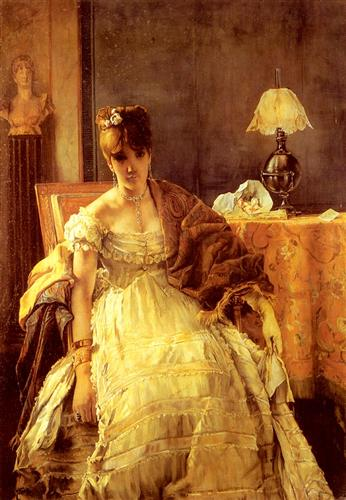Analyze the image in a comprehensive and detailed manner. This image is a stunning example of an oil painting executed with remarkable realism. The focal figure is an elegantly dressed woman in a sumptuous yellow gown, accented with a richly textured brown shawl and a delicate pearl necklace. She sits gracefully on a plush sofa, her demeanor calm and poised. A beautifully crafted table beside her holds a classic lamp with an ornate base and a decorative vase, providing a glimpse into her refined lifestyle. The backdrop is a muted gray wall, which interestingly hosts a detailed statue of a woman, adding a striking three-dimensional effect and narrative depth to the composition. The artist has expertly used a warm palette dominated by yellows, browns, and grays, harmonizing the elements and evoking a sense of tranquil elegance. This portrait not only focuses on the woman's physical likeness but also conveys a serene, introspective moment, masterfully captured by the artist's sophisticated use of color and form. 